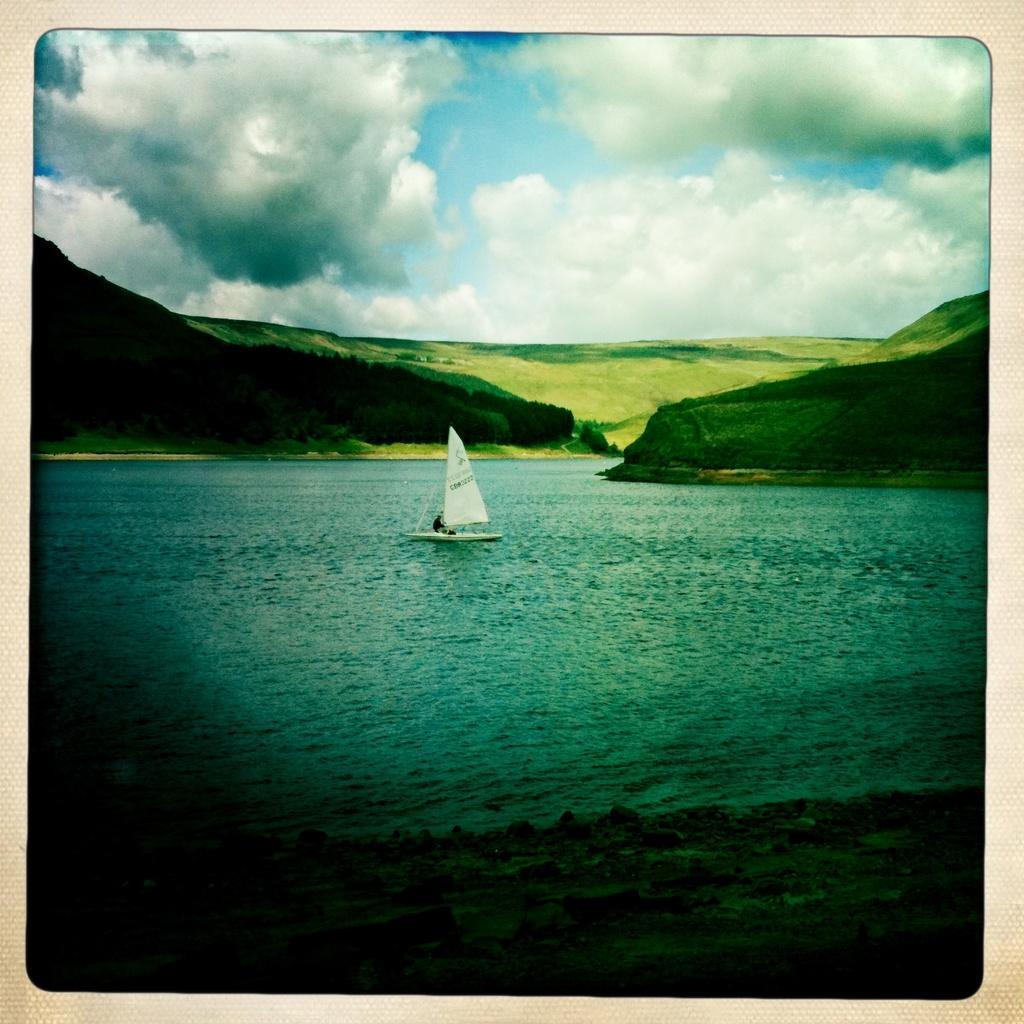How would you summarize this image in a sentence or two? In this picture I can see the mountains, one like, some sand, one boat in the lake, some trees, bushes, plants and grass on the surface. There is one person sailing the boat and at the top there is the cloudy sky. 